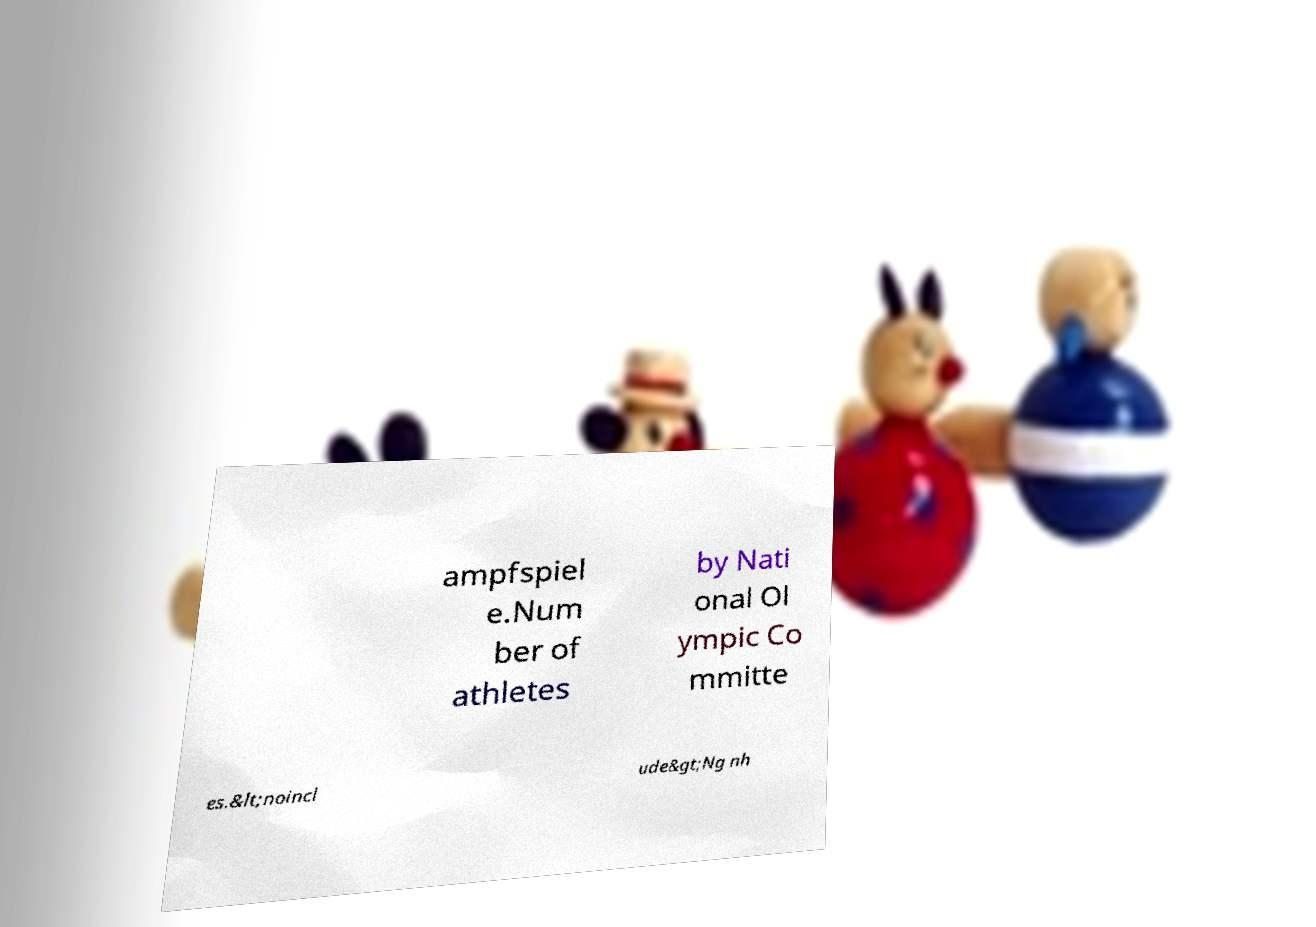Please identify and transcribe the text found in this image. ampfspiel e.Num ber of athletes by Nati onal Ol ympic Co mmitte es.&lt;noincl ude&gt;Ng nh 